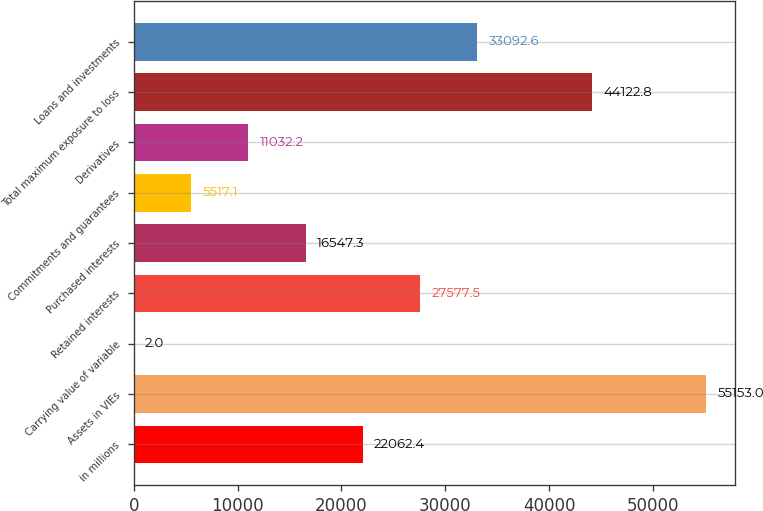<chart> <loc_0><loc_0><loc_500><loc_500><bar_chart><fcel>in millions<fcel>Assets in VIEs<fcel>Carrying value of variable<fcel>Retained interests<fcel>Purchased interests<fcel>Commitments and guarantees<fcel>Derivatives<fcel>Total maximum exposure to loss<fcel>Loans and investments<nl><fcel>22062.4<fcel>55153<fcel>2<fcel>27577.5<fcel>16547.3<fcel>5517.1<fcel>11032.2<fcel>44122.8<fcel>33092.6<nl></chart> 